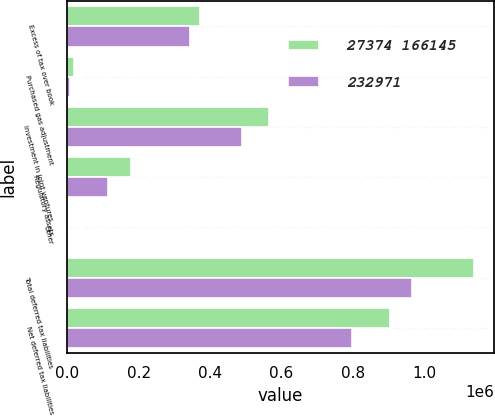<chart> <loc_0><loc_0><loc_500><loc_500><stacked_bar_chart><ecel><fcel>Excess of tax over book<fcel>Purchased gas adjustment<fcel>Investment in joint ventures<fcel>Regulatory assets<fcel>Other<fcel>Total deferred tax liabilities<fcel>Net deferred tax liabilities<nl><fcel>27374 166145<fcel>372123<fcel>20047<fcel>564234<fcel>180037<fcel>746<fcel>1.13719e+06<fcel>904216<nl><fcel>232971<fcel>344601<fcel>9015<fcel>490093<fcel>115689<fcel>2720<fcel>963685<fcel>797540<nl></chart> 